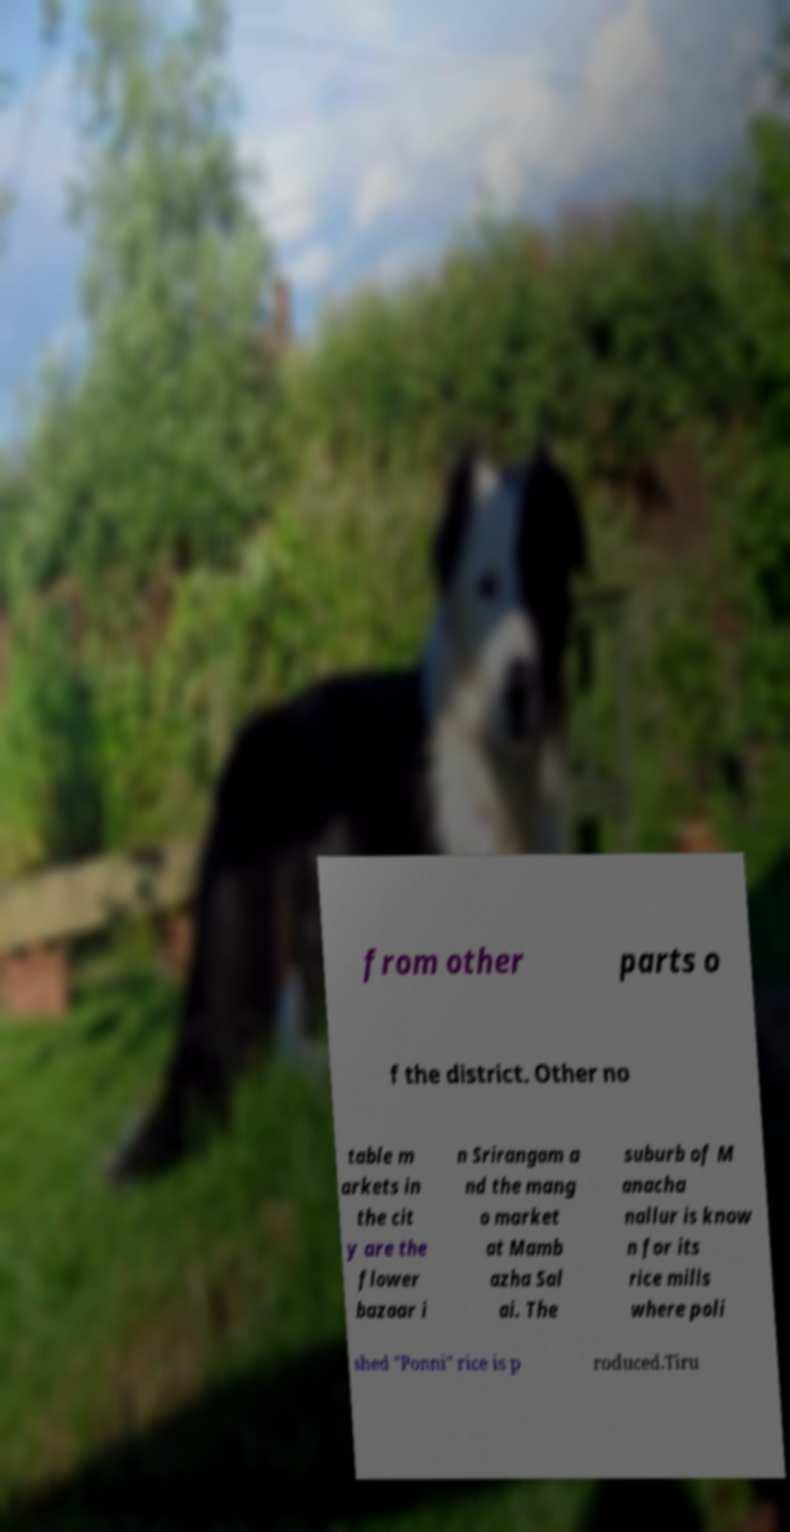For documentation purposes, I need the text within this image transcribed. Could you provide that? from other parts o f the district. Other no table m arkets in the cit y are the flower bazaar i n Srirangam a nd the mang o market at Mamb azha Sal ai. The suburb of M anacha nallur is know n for its rice mills where poli shed "Ponni" rice is p roduced.Tiru 